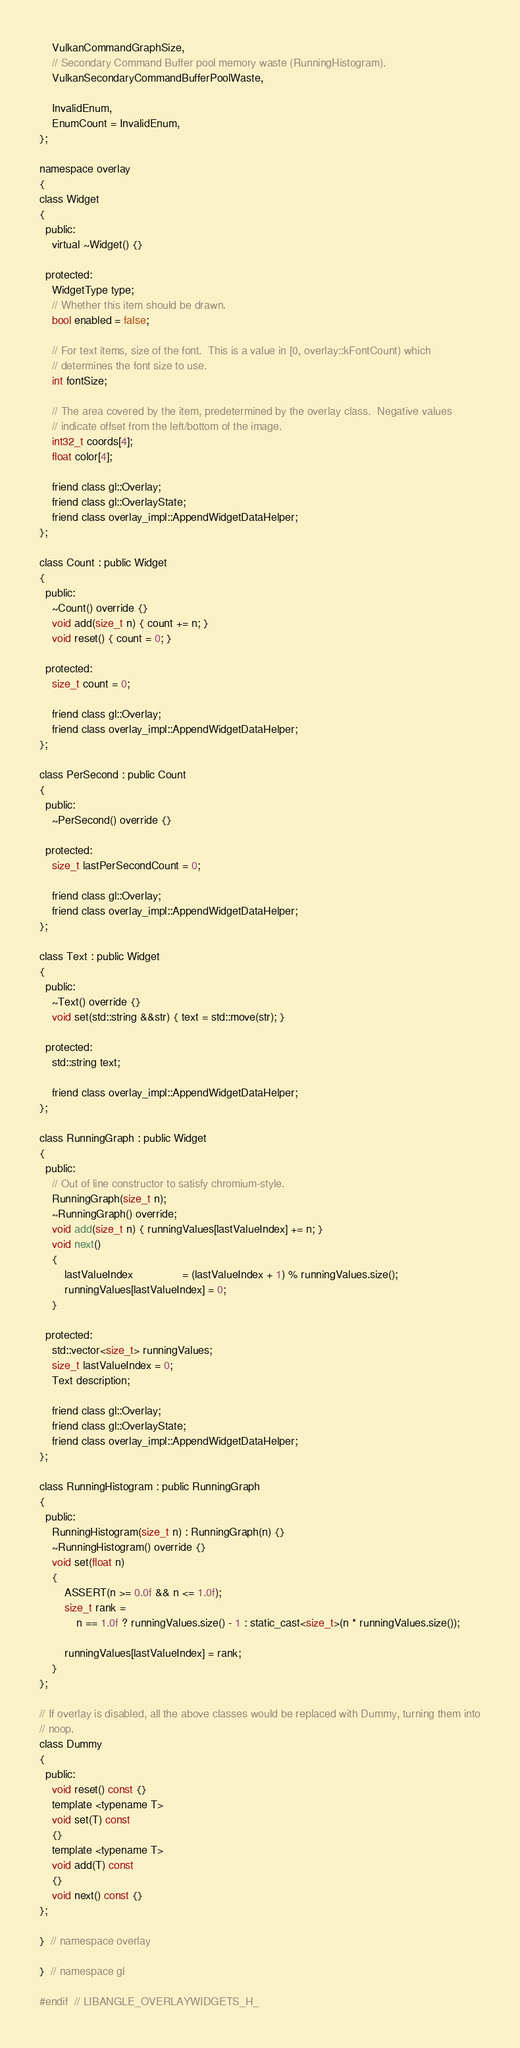Convert code to text. <code><loc_0><loc_0><loc_500><loc_500><_C_>    VulkanCommandGraphSize,
    // Secondary Command Buffer pool memory waste (RunningHistogram).
    VulkanSecondaryCommandBufferPoolWaste,

    InvalidEnum,
    EnumCount = InvalidEnum,
};

namespace overlay
{
class Widget
{
  public:
    virtual ~Widget() {}

  protected:
    WidgetType type;
    // Whether this item should be drawn.
    bool enabled = false;

    // For text items, size of the font.  This is a value in [0, overlay::kFontCount) which
    // determines the font size to use.
    int fontSize;

    // The area covered by the item, predetermined by the overlay class.  Negative values
    // indicate offset from the left/bottom of the image.
    int32_t coords[4];
    float color[4];

    friend class gl::Overlay;
    friend class gl::OverlayState;
    friend class overlay_impl::AppendWidgetDataHelper;
};

class Count : public Widget
{
  public:
    ~Count() override {}
    void add(size_t n) { count += n; }
    void reset() { count = 0; }

  protected:
    size_t count = 0;

    friend class gl::Overlay;
    friend class overlay_impl::AppendWidgetDataHelper;
};

class PerSecond : public Count
{
  public:
    ~PerSecond() override {}

  protected:
    size_t lastPerSecondCount = 0;

    friend class gl::Overlay;
    friend class overlay_impl::AppendWidgetDataHelper;
};

class Text : public Widget
{
  public:
    ~Text() override {}
    void set(std::string &&str) { text = std::move(str); }

  protected:
    std::string text;

    friend class overlay_impl::AppendWidgetDataHelper;
};

class RunningGraph : public Widget
{
  public:
    // Out of line constructor to satisfy chromium-style.
    RunningGraph(size_t n);
    ~RunningGraph() override;
    void add(size_t n) { runningValues[lastValueIndex] += n; }
    void next()
    {
        lastValueIndex                = (lastValueIndex + 1) % runningValues.size();
        runningValues[lastValueIndex] = 0;
    }

  protected:
    std::vector<size_t> runningValues;
    size_t lastValueIndex = 0;
    Text description;

    friend class gl::Overlay;
    friend class gl::OverlayState;
    friend class overlay_impl::AppendWidgetDataHelper;
};

class RunningHistogram : public RunningGraph
{
  public:
    RunningHistogram(size_t n) : RunningGraph(n) {}
    ~RunningHistogram() override {}
    void set(float n)
    {
        ASSERT(n >= 0.0f && n <= 1.0f);
        size_t rank =
            n == 1.0f ? runningValues.size() - 1 : static_cast<size_t>(n * runningValues.size());

        runningValues[lastValueIndex] = rank;
    }
};

// If overlay is disabled, all the above classes would be replaced with Dummy, turning them into
// noop.
class Dummy
{
  public:
    void reset() const {}
    template <typename T>
    void set(T) const
    {}
    template <typename T>
    void add(T) const
    {}
    void next() const {}
};

}  // namespace overlay

}  // namespace gl

#endif  // LIBANGLE_OVERLAYWIDGETS_H_
</code> 